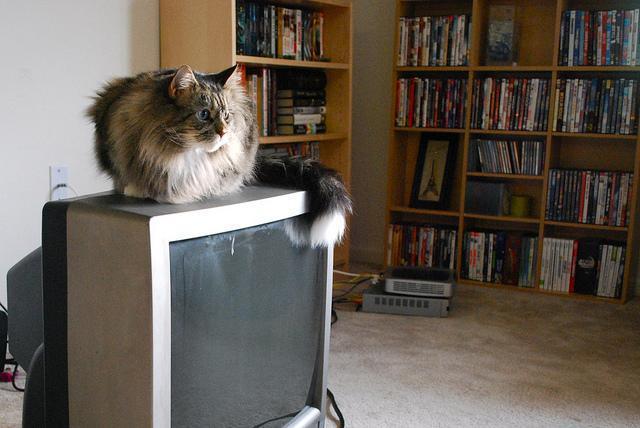How many books are visible?
Give a very brief answer. 2. 